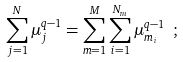Convert formula to latex. <formula><loc_0><loc_0><loc_500><loc_500>\sum _ { j = 1 } ^ { N } \mu _ { j } ^ { q - 1 } = \sum _ { m = 1 } ^ { M } \sum _ { i = 1 } ^ { N _ { m } } \mu _ { m _ { i } } ^ { q - 1 } \ ;</formula> 